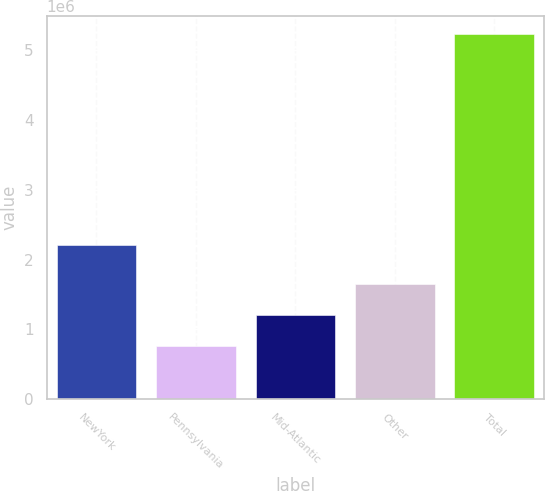Convert chart to OTSL. <chart><loc_0><loc_0><loc_500><loc_500><bar_chart><fcel>NewYork<fcel>Pennsylvania<fcel>Mid-Atlantic<fcel>Other<fcel>Total<nl><fcel>2.20874e+06<fcel>760965<fcel>1.20813e+06<fcel>1.6553e+06<fcel>5.23262e+06<nl></chart> 